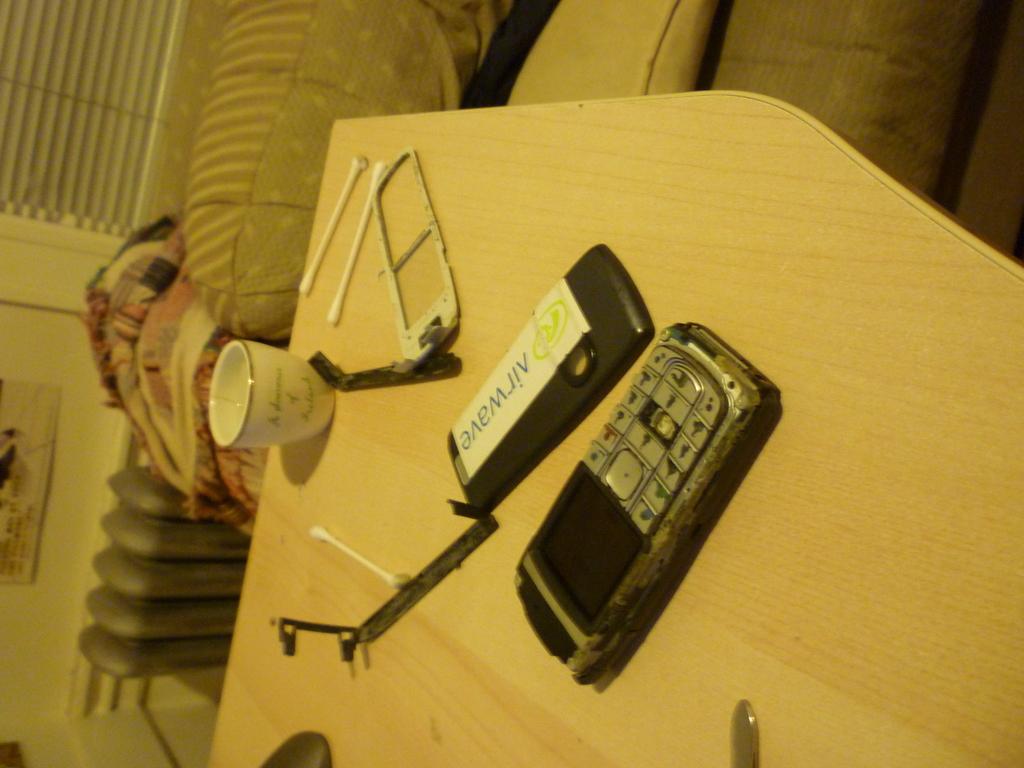Is there an upside v on this?
Offer a terse response. Yes. What is printed on the label on the cover?
Your response must be concise. Airwave. 